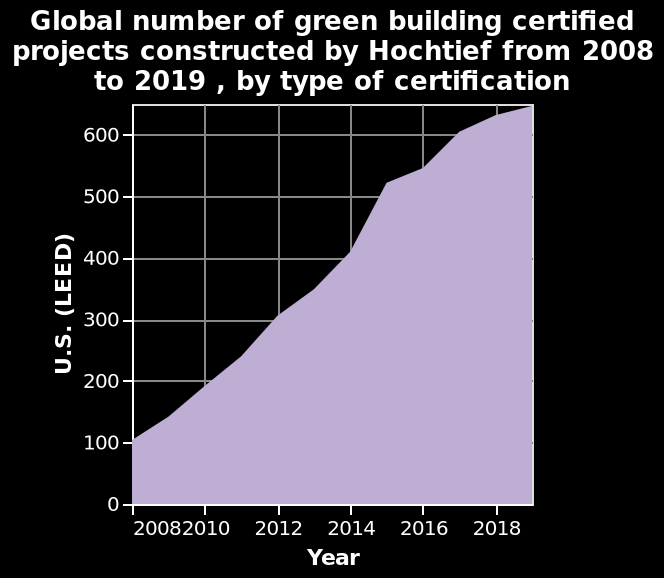<image>
Did Hochtief experience a decline in the construction of green building certified projects between 2008 and 2019? No, Hochtief saw a steady increase in the construction of green building certified projects from 2008 to 2019. please describe the details of the chart Here a is a area graph labeled Global number of green building certified projects constructed by Hochtief from 2008 to 2019 , by type of certification. The x-axis shows Year on linear scale from 2008 to 2018 while the y-axis shows U.S. (LEED) using linear scale of range 0 to 600. What is the x-axis of the area graph?  The x-axis of the area graph shows the years from 2008 to 2018 on a linear scale. 